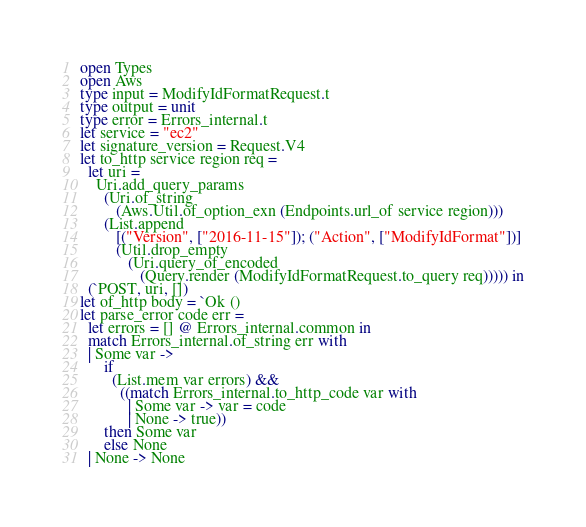Convert code to text. <code><loc_0><loc_0><loc_500><loc_500><_OCaml_>open Types
open Aws
type input = ModifyIdFormatRequest.t
type output = unit
type error = Errors_internal.t
let service = "ec2"
let signature_version = Request.V4
let to_http service region req =
  let uri =
    Uri.add_query_params
      (Uri.of_string
         (Aws.Util.of_option_exn (Endpoints.url_of service region)))
      (List.append
         [("Version", ["2016-11-15"]); ("Action", ["ModifyIdFormat"])]
         (Util.drop_empty
            (Uri.query_of_encoded
               (Query.render (ModifyIdFormatRequest.to_query req))))) in
  (`POST, uri, [])
let of_http body = `Ok ()
let parse_error code err =
  let errors = [] @ Errors_internal.common in
  match Errors_internal.of_string err with
  | Some var ->
      if
        (List.mem var errors) &&
          ((match Errors_internal.to_http_code var with
            | Some var -> var = code
            | None -> true))
      then Some var
      else None
  | None -> None</code> 